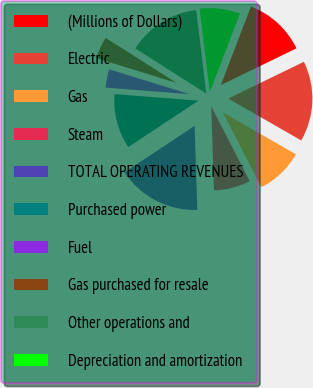Convert chart to OTSL. <chart><loc_0><loc_0><loc_500><loc_500><pie_chart><fcel>(Millions of Dollars)<fcel>Electric<fcel>Gas<fcel>Steam<fcel>TOTAL OPERATING REVENUES<fcel>Purchased power<fcel>Fuel<fcel>Gas purchased for resale<fcel>Other operations and<fcel>Depreciation and amortization<nl><fcel>11.97%<fcel>15.49%<fcel>9.16%<fcel>7.04%<fcel>16.2%<fcel>10.56%<fcel>3.52%<fcel>4.23%<fcel>14.08%<fcel>7.75%<nl></chart> 